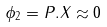<formula> <loc_0><loc_0><loc_500><loc_500>\phi _ { 2 } = P . X \approx 0</formula> 